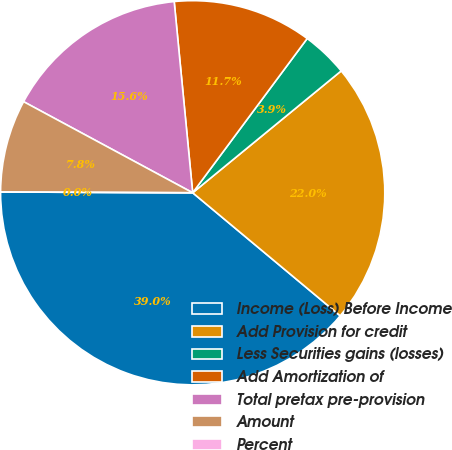Convert chart. <chart><loc_0><loc_0><loc_500><loc_500><pie_chart><fcel>Income (Loss) Before Income<fcel>Add Provision for credit<fcel>Less Securities gains (losses)<fcel>Add Amortization of<fcel>Total pretax pre-provision<fcel>Amount<fcel>Percent<nl><fcel>39.0%<fcel>22.0%<fcel>3.9%<fcel>11.7%<fcel>15.6%<fcel>7.8%<fcel>0.0%<nl></chart> 